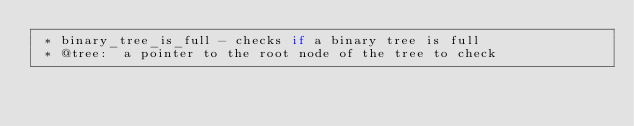<code> <loc_0><loc_0><loc_500><loc_500><_C_> * binary_tree_is_full - checks if a binary tree is full
 * @tree:  a pointer to the root node of the tree to check</code> 